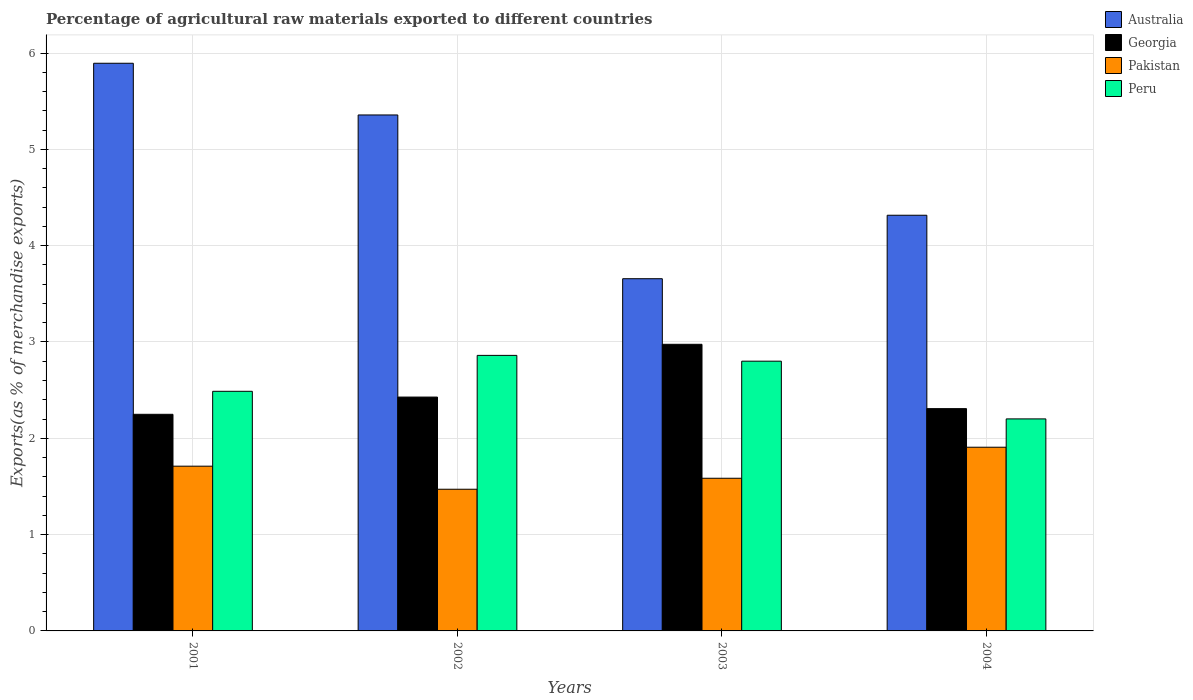How many different coloured bars are there?
Ensure brevity in your answer.  4. How many groups of bars are there?
Provide a short and direct response. 4. Are the number of bars on each tick of the X-axis equal?
Your answer should be very brief. Yes. What is the percentage of exports to different countries in Peru in 2003?
Keep it short and to the point. 2.8. Across all years, what is the maximum percentage of exports to different countries in Peru?
Your answer should be very brief. 2.86. Across all years, what is the minimum percentage of exports to different countries in Peru?
Ensure brevity in your answer.  2.2. In which year was the percentage of exports to different countries in Australia maximum?
Ensure brevity in your answer.  2001. In which year was the percentage of exports to different countries in Pakistan minimum?
Provide a succinct answer. 2002. What is the total percentage of exports to different countries in Peru in the graph?
Your answer should be compact. 10.35. What is the difference between the percentage of exports to different countries in Peru in 2001 and that in 2003?
Provide a succinct answer. -0.31. What is the difference between the percentage of exports to different countries in Pakistan in 2003 and the percentage of exports to different countries in Australia in 2002?
Make the answer very short. -3.77. What is the average percentage of exports to different countries in Peru per year?
Provide a short and direct response. 2.59. In the year 2004, what is the difference between the percentage of exports to different countries in Peru and percentage of exports to different countries in Australia?
Your answer should be compact. -2.11. In how many years, is the percentage of exports to different countries in Georgia greater than 5.4 %?
Make the answer very short. 0. What is the ratio of the percentage of exports to different countries in Australia in 2001 to that in 2004?
Give a very brief answer. 1.37. What is the difference between the highest and the second highest percentage of exports to different countries in Georgia?
Provide a short and direct response. 0.55. What is the difference between the highest and the lowest percentage of exports to different countries in Pakistan?
Make the answer very short. 0.44. In how many years, is the percentage of exports to different countries in Pakistan greater than the average percentage of exports to different countries in Pakistan taken over all years?
Provide a short and direct response. 2. What does the 1st bar from the right in 2002 represents?
Ensure brevity in your answer.  Peru. Is it the case that in every year, the sum of the percentage of exports to different countries in Pakistan and percentage of exports to different countries in Peru is greater than the percentage of exports to different countries in Georgia?
Make the answer very short. Yes. Are all the bars in the graph horizontal?
Ensure brevity in your answer.  No. What is the difference between two consecutive major ticks on the Y-axis?
Offer a terse response. 1. Are the values on the major ticks of Y-axis written in scientific E-notation?
Provide a short and direct response. No. Does the graph contain grids?
Make the answer very short. Yes. How many legend labels are there?
Give a very brief answer. 4. How are the legend labels stacked?
Ensure brevity in your answer.  Vertical. What is the title of the graph?
Your response must be concise. Percentage of agricultural raw materials exported to different countries. What is the label or title of the X-axis?
Provide a short and direct response. Years. What is the label or title of the Y-axis?
Offer a terse response. Exports(as % of merchandise exports). What is the Exports(as % of merchandise exports) of Australia in 2001?
Your answer should be compact. 5.89. What is the Exports(as % of merchandise exports) of Georgia in 2001?
Your answer should be compact. 2.25. What is the Exports(as % of merchandise exports) of Pakistan in 2001?
Offer a terse response. 1.71. What is the Exports(as % of merchandise exports) in Peru in 2001?
Keep it short and to the point. 2.49. What is the Exports(as % of merchandise exports) in Australia in 2002?
Provide a succinct answer. 5.36. What is the Exports(as % of merchandise exports) in Georgia in 2002?
Offer a terse response. 2.43. What is the Exports(as % of merchandise exports) of Pakistan in 2002?
Keep it short and to the point. 1.47. What is the Exports(as % of merchandise exports) in Peru in 2002?
Give a very brief answer. 2.86. What is the Exports(as % of merchandise exports) of Australia in 2003?
Provide a succinct answer. 3.66. What is the Exports(as % of merchandise exports) of Georgia in 2003?
Your response must be concise. 2.98. What is the Exports(as % of merchandise exports) in Pakistan in 2003?
Make the answer very short. 1.59. What is the Exports(as % of merchandise exports) in Peru in 2003?
Your answer should be very brief. 2.8. What is the Exports(as % of merchandise exports) in Australia in 2004?
Your answer should be compact. 4.32. What is the Exports(as % of merchandise exports) of Georgia in 2004?
Your response must be concise. 2.31. What is the Exports(as % of merchandise exports) of Pakistan in 2004?
Ensure brevity in your answer.  1.91. What is the Exports(as % of merchandise exports) in Peru in 2004?
Ensure brevity in your answer.  2.2. Across all years, what is the maximum Exports(as % of merchandise exports) of Australia?
Give a very brief answer. 5.89. Across all years, what is the maximum Exports(as % of merchandise exports) of Georgia?
Offer a very short reply. 2.98. Across all years, what is the maximum Exports(as % of merchandise exports) in Pakistan?
Offer a very short reply. 1.91. Across all years, what is the maximum Exports(as % of merchandise exports) in Peru?
Offer a terse response. 2.86. Across all years, what is the minimum Exports(as % of merchandise exports) in Australia?
Ensure brevity in your answer.  3.66. Across all years, what is the minimum Exports(as % of merchandise exports) in Georgia?
Your answer should be compact. 2.25. Across all years, what is the minimum Exports(as % of merchandise exports) in Pakistan?
Offer a terse response. 1.47. Across all years, what is the minimum Exports(as % of merchandise exports) in Peru?
Make the answer very short. 2.2. What is the total Exports(as % of merchandise exports) of Australia in the graph?
Offer a very short reply. 19.22. What is the total Exports(as % of merchandise exports) of Georgia in the graph?
Give a very brief answer. 9.96. What is the total Exports(as % of merchandise exports) of Pakistan in the graph?
Your response must be concise. 6.67. What is the total Exports(as % of merchandise exports) in Peru in the graph?
Your answer should be compact. 10.35. What is the difference between the Exports(as % of merchandise exports) in Australia in 2001 and that in 2002?
Your answer should be very brief. 0.54. What is the difference between the Exports(as % of merchandise exports) of Georgia in 2001 and that in 2002?
Give a very brief answer. -0.18. What is the difference between the Exports(as % of merchandise exports) of Pakistan in 2001 and that in 2002?
Keep it short and to the point. 0.24. What is the difference between the Exports(as % of merchandise exports) in Peru in 2001 and that in 2002?
Offer a terse response. -0.37. What is the difference between the Exports(as % of merchandise exports) of Australia in 2001 and that in 2003?
Provide a succinct answer. 2.24. What is the difference between the Exports(as % of merchandise exports) of Georgia in 2001 and that in 2003?
Offer a terse response. -0.73. What is the difference between the Exports(as % of merchandise exports) of Pakistan in 2001 and that in 2003?
Your answer should be compact. 0.13. What is the difference between the Exports(as % of merchandise exports) of Peru in 2001 and that in 2003?
Provide a succinct answer. -0.31. What is the difference between the Exports(as % of merchandise exports) in Australia in 2001 and that in 2004?
Provide a succinct answer. 1.58. What is the difference between the Exports(as % of merchandise exports) in Georgia in 2001 and that in 2004?
Provide a succinct answer. -0.06. What is the difference between the Exports(as % of merchandise exports) of Pakistan in 2001 and that in 2004?
Ensure brevity in your answer.  -0.2. What is the difference between the Exports(as % of merchandise exports) in Peru in 2001 and that in 2004?
Provide a succinct answer. 0.29. What is the difference between the Exports(as % of merchandise exports) in Australia in 2002 and that in 2003?
Provide a succinct answer. 1.7. What is the difference between the Exports(as % of merchandise exports) in Georgia in 2002 and that in 2003?
Give a very brief answer. -0.55. What is the difference between the Exports(as % of merchandise exports) of Pakistan in 2002 and that in 2003?
Provide a succinct answer. -0.11. What is the difference between the Exports(as % of merchandise exports) of Peru in 2002 and that in 2003?
Offer a terse response. 0.06. What is the difference between the Exports(as % of merchandise exports) in Australia in 2002 and that in 2004?
Provide a short and direct response. 1.04. What is the difference between the Exports(as % of merchandise exports) in Georgia in 2002 and that in 2004?
Make the answer very short. 0.12. What is the difference between the Exports(as % of merchandise exports) of Pakistan in 2002 and that in 2004?
Your answer should be compact. -0.44. What is the difference between the Exports(as % of merchandise exports) of Peru in 2002 and that in 2004?
Give a very brief answer. 0.66. What is the difference between the Exports(as % of merchandise exports) of Australia in 2003 and that in 2004?
Your answer should be compact. -0.66. What is the difference between the Exports(as % of merchandise exports) of Georgia in 2003 and that in 2004?
Offer a very short reply. 0.67. What is the difference between the Exports(as % of merchandise exports) of Pakistan in 2003 and that in 2004?
Give a very brief answer. -0.32. What is the difference between the Exports(as % of merchandise exports) in Peru in 2003 and that in 2004?
Make the answer very short. 0.6. What is the difference between the Exports(as % of merchandise exports) in Australia in 2001 and the Exports(as % of merchandise exports) in Georgia in 2002?
Make the answer very short. 3.47. What is the difference between the Exports(as % of merchandise exports) in Australia in 2001 and the Exports(as % of merchandise exports) in Pakistan in 2002?
Keep it short and to the point. 4.42. What is the difference between the Exports(as % of merchandise exports) in Australia in 2001 and the Exports(as % of merchandise exports) in Peru in 2002?
Offer a very short reply. 3.03. What is the difference between the Exports(as % of merchandise exports) in Georgia in 2001 and the Exports(as % of merchandise exports) in Pakistan in 2002?
Make the answer very short. 0.78. What is the difference between the Exports(as % of merchandise exports) of Georgia in 2001 and the Exports(as % of merchandise exports) of Peru in 2002?
Keep it short and to the point. -0.61. What is the difference between the Exports(as % of merchandise exports) in Pakistan in 2001 and the Exports(as % of merchandise exports) in Peru in 2002?
Ensure brevity in your answer.  -1.15. What is the difference between the Exports(as % of merchandise exports) of Australia in 2001 and the Exports(as % of merchandise exports) of Georgia in 2003?
Your answer should be very brief. 2.92. What is the difference between the Exports(as % of merchandise exports) in Australia in 2001 and the Exports(as % of merchandise exports) in Pakistan in 2003?
Offer a very short reply. 4.31. What is the difference between the Exports(as % of merchandise exports) of Australia in 2001 and the Exports(as % of merchandise exports) of Peru in 2003?
Your answer should be very brief. 3.09. What is the difference between the Exports(as % of merchandise exports) of Georgia in 2001 and the Exports(as % of merchandise exports) of Pakistan in 2003?
Your answer should be compact. 0.66. What is the difference between the Exports(as % of merchandise exports) in Georgia in 2001 and the Exports(as % of merchandise exports) in Peru in 2003?
Ensure brevity in your answer.  -0.55. What is the difference between the Exports(as % of merchandise exports) of Pakistan in 2001 and the Exports(as % of merchandise exports) of Peru in 2003?
Give a very brief answer. -1.09. What is the difference between the Exports(as % of merchandise exports) in Australia in 2001 and the Exports(as % of merchandise exports) in Georgia in 2004?
Keep it short and to the point. 3.59. What is the difference between the Exports(as % of merchandise exports) in Australia in 2001 and the Exports(as % of merchandise exports) in Pakistan in 2004?
Offer a terse response. 3.99. What is the difference between the Exports(as % of merchandise exports) in Australia in 2001 and the Exports(as % of merchandise exports) in Peru in 2004?
Your response must be concise. 3.69. What is the difference between the Exports(as % of merchandise exports) in Georgia in 2001 and the Exports(as % of merchandise exports) in Pakistan in 2004?
Your answer should be very brief. 0.34. What is the difference between the Exports(as % of merchandise exports) of Georgia in 2001 and the Exports(as % of merchandise exports) of Peru in 2004?
Provide a succinct answer. 0.05. What is the difference between the Exports(as % of merchandise exports) in Pakistan in 2001 and the Exports(as % of merchandise exports) in Peru in 2004?
Offer a terse response. -0.49. What is the difference between the Exports(as % of merchandise exports) in Australia in 2002 and the Exports(as % of merchandise exports) in Georgia in 2003?
Provide a short and direct response. 2.38. What is the difference between the Exports(as % of merchandise exports) of Australia in 2002 and the Exports(as % of merchandise exports) of Pakistan in 2003?
Keep it short and to the point. 3.77. What is the difference between the Exports(as % of merchandise exports) of Australia in 2002 and the Exports(as % of merchandise exports) of Peru in 2003?
Your answer should be very brief. 2.56. What is the difference between the Exports(as % of merchandise exports) in Georgia in 2002 and the Exports(as % of merchandise exports) in Pakistan in 2003?
Keep it short and to the point. 0.84. What is the difference between the Exports(as % of merchandise exports) of Georgia in 2002 and the Exports(as % of merchandise exports) of Peru in 2003?
Provide a succinct answer. -0.37. What is the difference between the Exports(as % of merchandise exports) of Pakistan in 2002 and the Exports(as % of merchandise exports) of Peru in 2003?
Give a very brief answer. -1.33. What is the difference between the Exports(as % of merchandise exports) of Australia in 2002 and the Exports(as % of merchandise exports) of Georgia in 2004?
Make the answer very short. 3.05. What is the difference between the Exports(as % of merchandise exports) in Australia in 2002 and the Exports(as % of merchandise exports) in Pakistan in 2004?
Your answer should be very brief. 3.45. What is the difference between the Exports(as % of merchandise exports) in Australia in 2002 and the Exports(as % of merchandise exports) in Peru in 2004?
Your response must be concise. 3.16. What is the difference between the Exports(as % of merchandise exports) in Georgia in 2002 and the Exports(as % of merchandise exports) in Pakistan in 2004?
Your answer should be compact. 0.52. What is the difference between the Exports(as % of merchandise exports) of Georgia in 2002 and the Exports(as % of merchandise exports) of Peru in 2004?
Provide a succinct answer. 0.23. What is the difference between the Exports(as % of merchandise exports) of Pakistan in 2002 and the Exports(as % of merchandise exports) of Peru in 2004?
Offer a terse response. -0.73. What is the difference between the Exports(as % of merchandise exports) in Australia in 2003 and the Exports(as % of merchandise exports) in Georgia in 2004?
Ensure brevity in your answer.  1.35. What is the difference between the Exports(as % of merchandise exports) in Australia in 2003 and the Exports(as % of merchandise exports) in Pakistan in 2004?
Offer a terse response. 1.75. What is the difference between the Exports(as % of merchandise exports) in Australia in 2003 and the Exports(as % of merchandise exports) in Peru in 2004?
Make the answer very short. 1.46. What is the difference between the Exports(as % of merchandise exports) in Georgia in 2003 and the Exports(as % of merchandise exports) in Pakistan in 2004?
Offer a terse response. 1.07. What is the difference between the Exports(as % of merchandise exports) of Georgia in 2003 and the Exports(as % of merchandise exports) of Peru in 2004?
Provide a short and direct response. 0.77. What is the difference between the Exports(as % of merchandise exports) of Pakistan in 2003 and the Exports(as % of merchandise exports) of Peru in 2004?
Your answer should be compact. -0.62. What is the average Exports(as % of merchandise exports) in Australia per year?
Make the answer very short. 4.81. What is the average Exports(as % of merchandise exports) in Georgia per year?
Your response must be concise. 2.49. What is the average Exports(as % of merchandise exports) of Pakistan per year?
Ensure brevity in your answer.  1.67. What is the average Exports(as % of merchandise exports) of Peru per year?
Keep it short and to the point. 2.59. In the year 2001, what is the difference between the Exports(as % of merchandise exports) in Australia and Exports(as % of merchandise exports) in Georgia?
Give a very brief answer. 3.65. In the year 2001, what is the difference between the Exports(as % of merchandise exports) of Australia and Exports(as % of merchandise exports) of Pakistan?
Make the answer very short. 4.18. In the year 2001, what is the difference between the Exports(as % of merchandise exports) in Australia and Exports(as % of merchandise exports) in Peru?
Provide a succinct answer. 3.41. In the year 2001, what is the difference between the Exports(as % of merchandise exports) in Georgia and Exports(as % of merchandise exports) in Pakistan?
Ensure brevity in your answer.  0.54. In the year 2001, what is the difference between the Exports(as % of merchandise exports) of Georgia and Exports(as % of merchandise exports) of Peru?
Your response must be concise. -0.24. In the year 2001, what is the difference between the Exports(as % of merchandise exports) in Pakistan and Exports(as % of merchandise exports) in Peru?
Provide a short and direct response. -0.78. In the year 2002, what is the difference between the Exports(as % of merchandise exports) in Australia and Exports(as % of merchandise exports) in Georgia?
Ensure brevity in your answer.  2.93. In the year 2002, what is the difference between the Exports(as % of merchandise exports) in Australia and Exports(as % of merchandise exports) in Pakistan?
Ensure brevity in your answer.  3.89. In the year 2002, what is the difference between the Exports(as % of merchandise exports) of Australia and Exports(as % of merchandise exports) of Peru?
Provide a short and direct response. 2.5. In the year 2002, what is the difference between the Exports(as % of merchandise exports) in Georgia and Exports(as % of merchandise exports) in Peru?
Provide a short and direct response. -0.43. In the year 2002, what is the difference between the Exports(as % of merchandise exports) in Pakistan and Exports(as % of merchandise exports) in Peru?
Your answer should be very brief. -1.39. In the year 2003, what is the difference between the Exports(as % of merchandise exports) of Australia and Exports(as % of merchandise exports) of Georgia?
Keep it short and to the point. 0.68. In the year 2003, what is the difference between the Exports(as % of merchandise exports) of Australia and Exports(as % of merchandise exports) of Pakistan?
Offer a very short reply. 2.07. In the year 2003, what is the difference between the Exports(as % of merchandise exports) in Australia and Exports(as % of merchandise exports) in Peru?
Give a very brief answer. 0.86. In the year 2003, what is the difference between the Exports(as % of merchandise exports) of Georgia and Exports(as % of merchandise exports) of Pakistan?
Provide a short and direct response. 1.39. In the year 2003, what is the difference between the Exports(as % of merchandise exports) in Georgia and Exports(as % of merchandise exports) in Peru?
Provide a succinct answer. 0.18. In the year 2003, what is the difference between the Exports(as % of merchandise exports) in Pakistan and Exports(as % of merchandise exports) in Peru?
Keep it short and to the point. -1.22. In the year 2004, what is the difference between the Exports(as % of merchandise exports) of Australia and Exports(as % of merchandise exports) of Georgia?
Your answer should be very brief. 2.01. In the year 2004, what is the difference between the Exports(as % of merchandise exports) in Australia and Exports(as % of merchandise exports) in Pakistan?
Offer a very short reply. 2.41. In the year 2004, what is the difference between the Exports(as % of merchandise exports) in Australia and Exports(as % of merchandise exports) in Peru?
Provide a short and direct response. 2.11. In the year 2004, what is the difference between the Exports(as % of merchandise exports) in Georgia and Exports(as % of merchandise exports) in Pakistan?
Make the answer very short. 0.4. In the year 2004, what is the difference between the Exports(as % of merchandise exports) in Georgia and Exports(as % of merchandise exports) in Peru?
Make the answer very short. 0.11. In the year 2004, what is the difference between the Exports(as % of merchandise exports) of Pakistan and Exports(as % of merchandise exports) of Peru?
Your answer should be compact. -0.29. What is the ratio of the Exports(as % of merchandise exports) of Australia in 2001 to that in 2002?
Your response must be concise. 1.1. What is the ratio of the Exports(as % of merchandise exports) in Georgia in 2001 to that in 2002?
Keep it short and to the point. 0.93. What is the ratio of the Exports(as % of merchandise exports) in Pakistan in 2001 to that in 2002?
Your response must be concise. 1.16. What is the ratio of the Exports(as % of merchandise exports) in Peru in 2001 to that in 2002?
Your answer should be very brief. 0.87. What is the ratio of the Exports(as % of merchandise exports) of Australia in 2001 to that in 2003?
Make the answer very short. 1.61. What is the ratio of the Exports(as % of merchandise exports) of Georgia in 2001 to that in 2003?
Make the answer very short. 0.76. What is the ratio of the Exports(as % of merchandise exports) in Pakistan in 2001 to that in 2003?
Offer a very short reply. 1.08. What is the ratio of the Exports(as % of merchandise exports) in Peru in 2001 to that in 2003?
Provide a succinct answer. 0.89. What is the ratio of the Exports(as % of merchandise exports) of Australia in 2001 to that in 2004?
Offer a very short reply. 1.37. What is the ratio of the Exports(as % of merchandise exports) of Georgia in 2001 to that in 2004?
Your response must be concise. 0.97. What is the ratio of the Exports(as % of merchandise exports) in Pakistan in 2001 to that in 2004?
Provide a short and direct response. 0.9. What is the ratio of the Exports(as % of merchandise exports) in Peru in 2001 to that in 2004?
Provide a succinct answer. 1.13. What is the ratio of the Exports(as % of merchandise exports) in Australia in 2002 to that in 2003?
Offer a terse response. 1.46. What is the ratio of the Exports(as % of merchandise exports) in Georgia in 2002 to that in 2003?
Provide a succinct answer. 0.82. What is the ratio of the Exports(as % of merchandise exports) of Pakistan in 2002 to that in 2003?
Your answer should be very brief. 0.93. What is the ratio of the Exports(as % of merchandise exports) of Peru in 2002 to that in 2003?
Make the answer very short. 1.02. What is the ratio of the Exports(as % of merchandise exports) of Australia in 2002 to that in 2004?
Your answer should be compact. 1.24. What is the ratio of the Exports(as % of merchandise exports) in Georgia in 2002 to that in 2004?
Your answer should be very brief. 1.05. What is the ratio of the Exports(as % of merchandise exports) of Pakistan in 2002 to that in 2004?
Your response must be concise. 0.77. What is the ratio of the Exports(as % of merchandise exports) in Peru in 2002 to that in 2004?
Give a very brief answer. 1.3. What is the ratio of the Exports(as % of merchandise exports) in Australia in 2003 to that in 2004?
Keep it short and to the point. 0.85. What is the ratio of the Exports(as % of merchandise exports) in Georgia in 2003 to that in 2004?
Provide a short and direct response. 1.29. What is the ratio of the Exports(as % of merchandise exports) in Pakistan in 2003 to that in 2004?
Your answer should be compact. 0.83. What is the ratio of the Exports(as % of merchandise exports) in Peru in 2003 to that in 2004?
Keep it short and to the point. 1.27. What is the difference between the highest and the second highest Exports(as % of merchandise exports) of Australia?
Provide a short and direct response. 0.54. What is the difference between the highest and the second highest Exports(as % of merchandise exports) in Georgia?
Your answer should be very brief. 0.55. What is the difference between the highest and the second highest Exports(as % of merchandise exports) of Pakistan?
Your response must be concise. 0.2. What is the difference between the highest and the second highest Exports(as % of merchandise exports) in Peru?
Your response must be concise. 0.06. What is the difference between the highest and the lowest Exports(as % of merchandise exports) of Australia?
Provide a succinct answer. 2.24. What is the difference between the highest and the lowest Exports(as % of merchandise exports) in Georgia?
Make the answer very short. 0.73. What is the difference between the highest and the lowest Exports(as % of merchandise exports) in Pakistan?
Keep it short and to the point. 0.44. What is the difference between the highest and the lowest Exports(as % of merchandise exports) in Peru?
Provide a succinct answer. 0.66. 